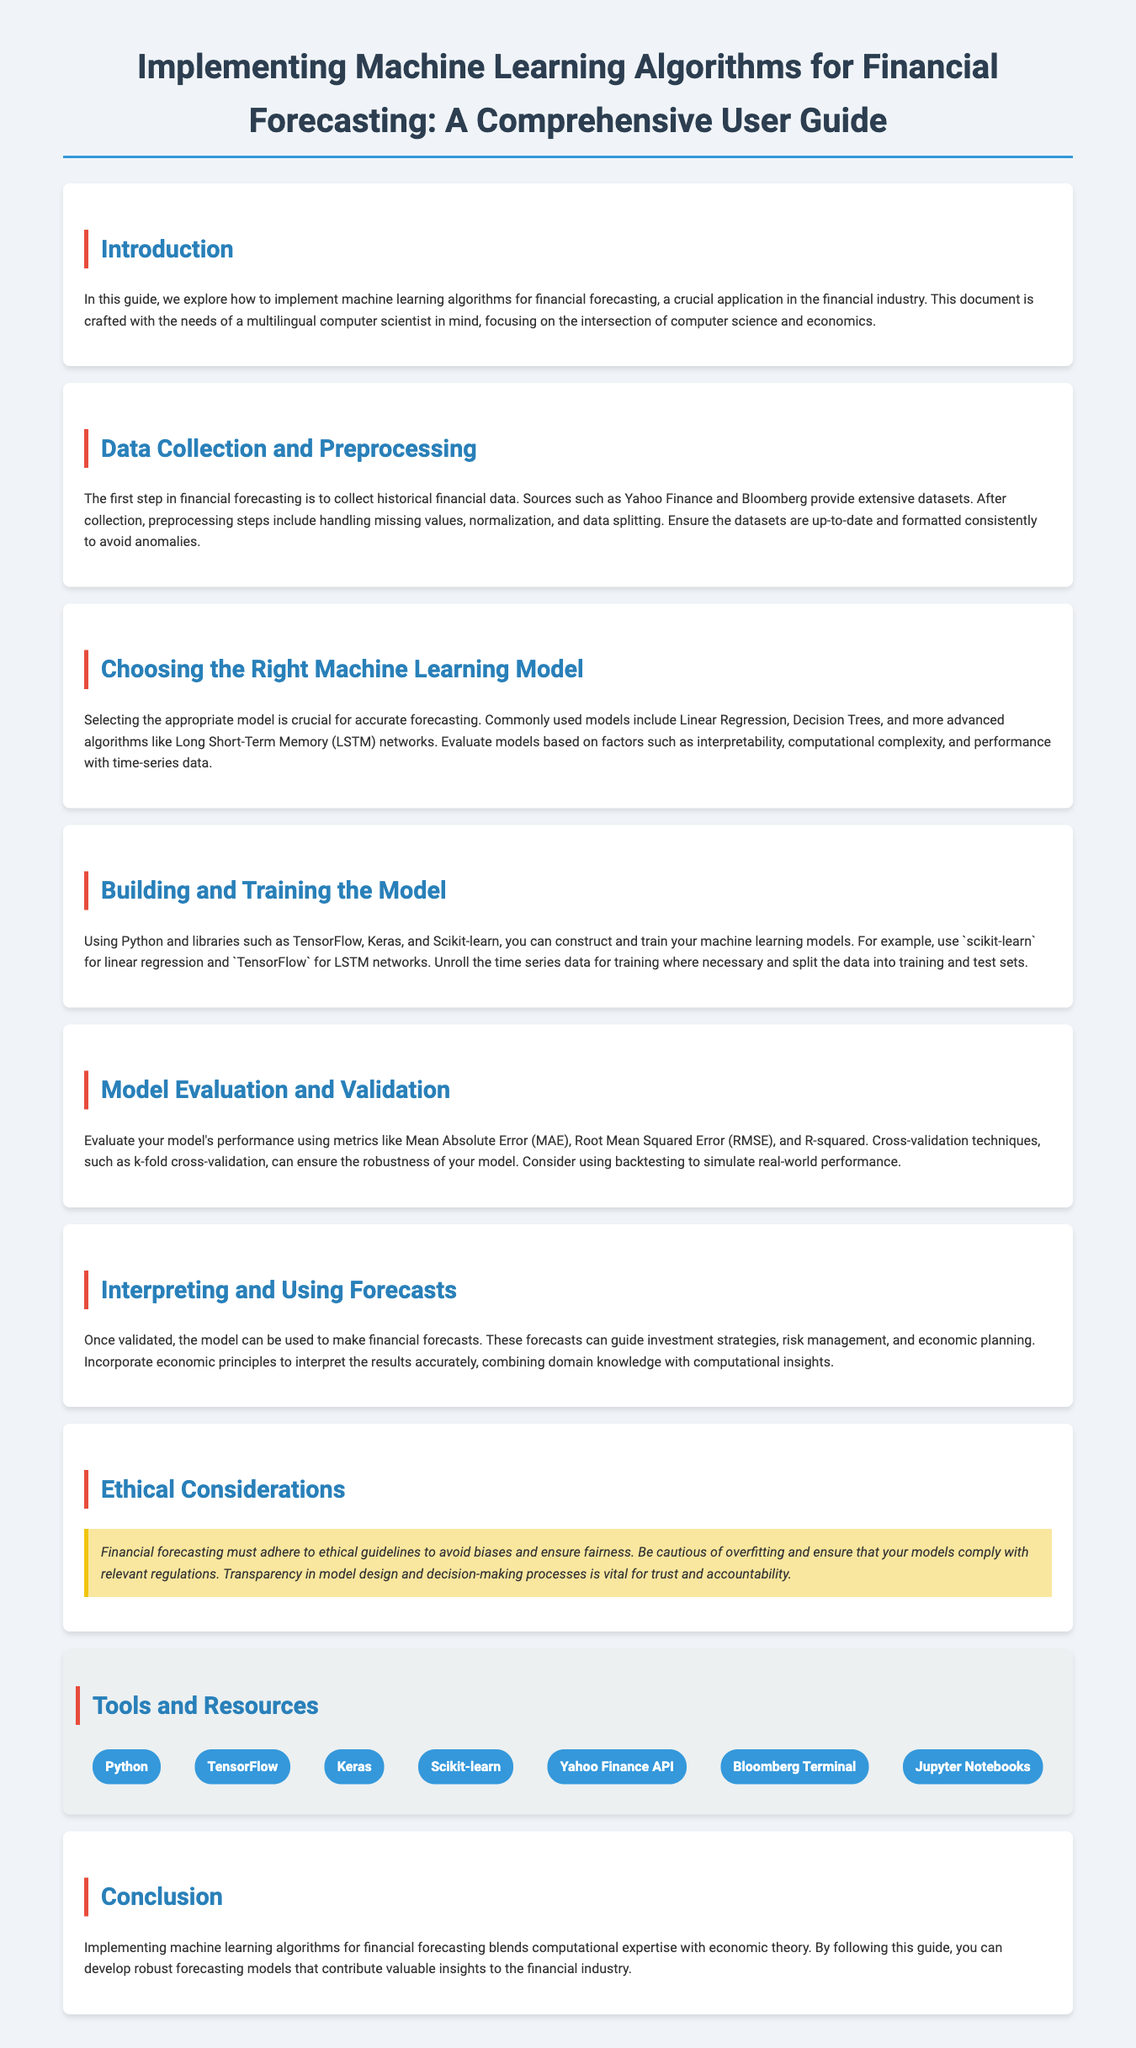What is the focus of this guide? The introduction states that the guide focuses on the implementation of machine learning algorithms for financial forecasting, particularly for a multilingual computer scientist.
Answer: Financial forecasting What are the common sources for historical financial data? The document mentions specific sources for historical financial data under data collection, including Yahoo Finance and Bloomberg.
Answer: Yahoo Finance and Bloomberg Which machine learning models are mentioned for financial forecasting? The section on choosing the right model lists commonly used models like Linear Regression and Decision Trees, as well as LSTM networks.
Answer: Linear Regression, Decision Trees, LSTM What metrics are suggested for evaluating model performance? The model evaluation section outlines various metrics, including Mean Absolute Error, Root Mean Squared Error, and R-squared.
Answer: Mean Absolute Error, Root Mean Squared Error, R-squared What is a key ethical consideration in financial forecasting? Under ethical considerations, it emphasizes the importance of adherence to ethical guidelines to avoid biases and ensure fairness.
Answer: Avoiding biases What programming language is primarily used in building and training models? The document repeatedly mentions Python as the primary programming language for implementing machine learning models.
Answer: Python How should the data be prepared before training the model? The data collection and preprocessing section specifies necessary preprocessing steps such as handling missing values, normalization, and data splitting.
Answer: Handling missing values, normalization, data splitting What is emphasized as important for model transparency? The ethical considerations section states that transparency in model design and decision-making processes is crucial for trust and accountability.
Answer: Transparency What tools are listed as resources for implementing machine learning algorithms? The tools and resources section provides a list of tools such as TensorFlow, Keras, and Scikit-learn used for financial forecasting.
Answer: TensorFlow, Keras, Scikit-learn 